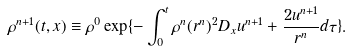<formula> <loc_0><loc_0><loc_500><loc_500>\rho ^ { n + 1 } ( t , x ) \equiv \rho ^ { 0 } \exp \{ - \int _ { 0 } ^ { t } \rho ^ { n } ( r ^ { n } ) ^ { 2 } D _ { x } u ^ { n + 1 } + \frac { 2 u ^ { n + 1 } } { r ^ { n } } d \tau \} .</formula> 